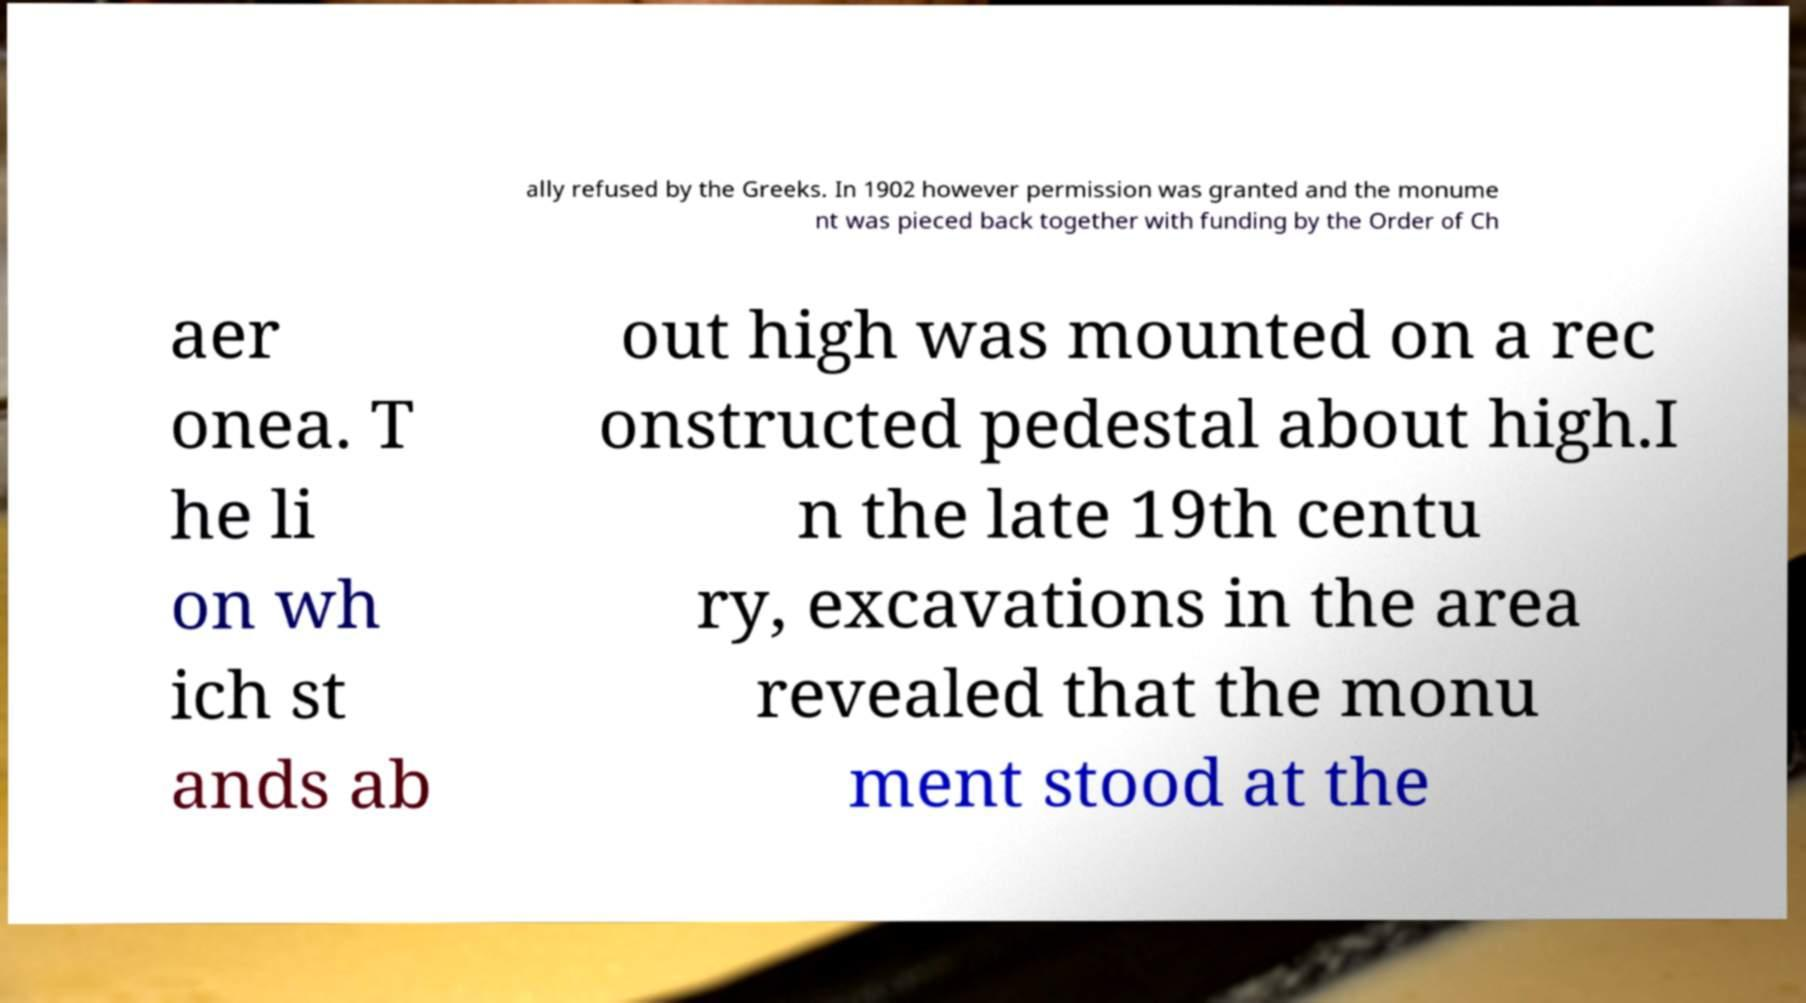Can you accurately transcribe the text from the provided image for me? ally refused by the Greeks. In 1902 however permission was granted and the monume nt was pieced back together with funding by the Order of Ch aer onea. T he li on wh ich st ands ab out high was mounted on a rec onstructed pedestal about high.I n the late 19th centu ry, excavations in the area revealed that the monu ment stood at the 